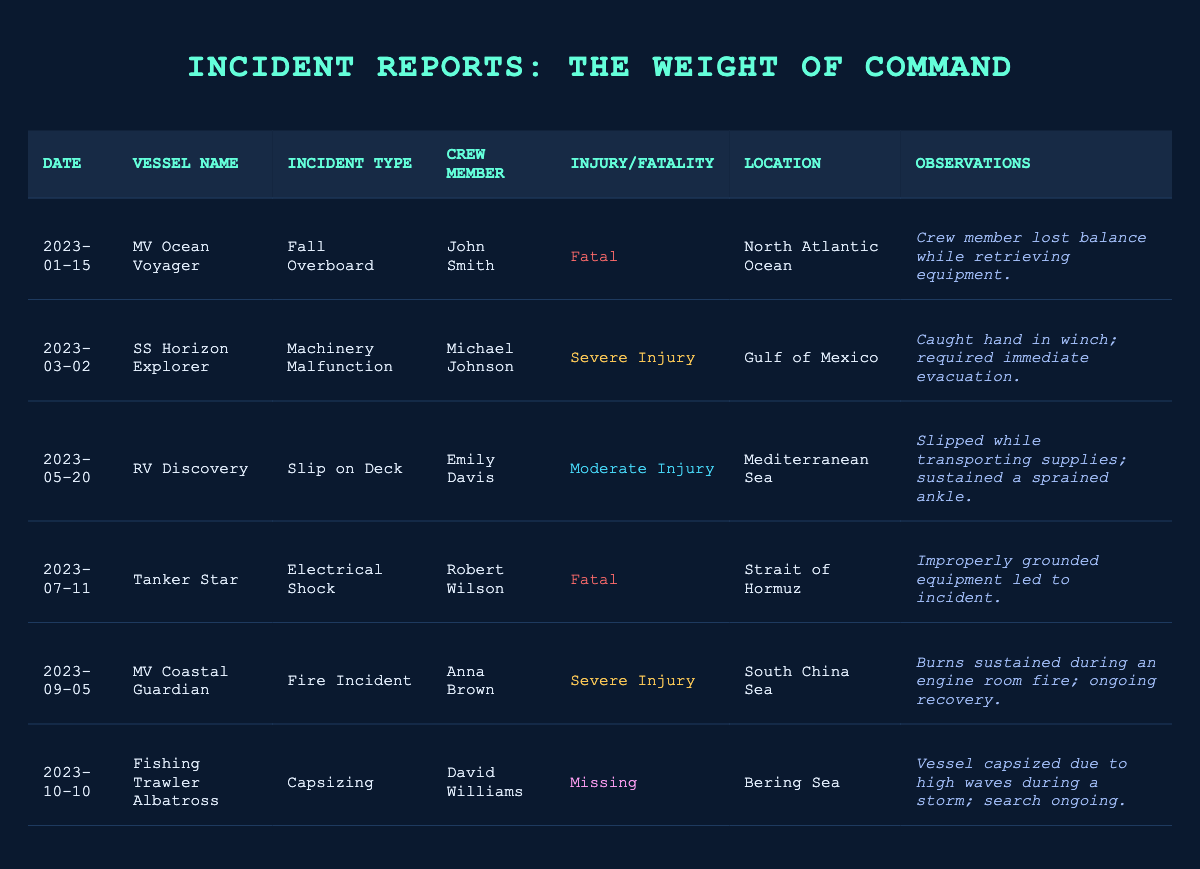What type of incident resulted in the most fatalities? There are two incidents marked as "Fatal," which are the "Fall Overboard" involving John Smith and the "Electrical Shock" involving Robert Wilson. Therefore, the incidents that resulted in the most fatalities are both cases.
Answer: Fall Overboard and Electrical Shock Which crew member was involved in a severe injury incident? The table shows two incidents classified as "Severe Injury": one involved Michael Johnson (Machinery Malfunction) and the other involved Anna Brown (Fire Incident). Thus, both crew members were involved in severe injury incidents.
Answer: Michael Johnson and Anna Brown How many incidents resulted in crew members being missing? Only one incident in the table is marked as "Missing," involving David Williams from the incident categorized as "Capsizing." Hence, there is just one missing crew member.
Answer: 1 Is there any crew member that experienced a moderate injury? Yes, Emily Davis experienced a "Moderate Injury" due to a slip on deck while transporting supplies. This confirms that there is indeed a moderate injury case.
Answer: Yes What are the locations of the incidents that resulted in fatalities? The fatalities occurred in the North Atlantic Ocean and the Strait of Hormuz. Thus, both locations are associated with incidents leading to fatalities.
Answer: North Atlantic Ocean and Strait of Hormuz Which incident type was the most common among the listed reports? There are three different types of incidents identified: "Fall Overboard," "Machinery Malfunction," and "Slip on Deck," but none of these repeat. Therefore, each type has a single occurrence.
Answer: Each incident type is unique What is the difference between the number of severe injury incidents and fatal incidents? There are a total of two severe injury incidents (Michael Johnson and Anna Brown) and two fatal incidents (John Smith and Robert Wilson). Thus, the difference is 2 - 2 = 0.
Answer: 0 List all individuals involved in incidents that resulted in injuries but not fatalities. The crew members involved in incidents that resulted in injuries but not fatalities are Michael Johnson (Severe Injury), Emily Davis (Moderate Injury), and Anna Brown (Severe Injury). This totals three individuals.
Answer: Michael Johnson, Emily Davis, Anna Brown What was the incident type for the crew member David Williams? David Williams was involved in a "Capsizing" incident as indicated in the table. Thus, this is the incident type associated with him.
Answer: Capsizing How many incidents were reported in the Mediterranean Sea? Only one incident is reported in the Mediterranean Sea, which involves Emily Davis. Therefore, the total number of incidents in that area is one.
Answer: 1 Were there any observations recorded for the incident involving Anna Brown? Yes, the observations for Anna Brown's incident state that she sustained burns during an engine room fire and is in ongoing recovery. Therefore, observations were recorded for this incident.
Answer: Yes 